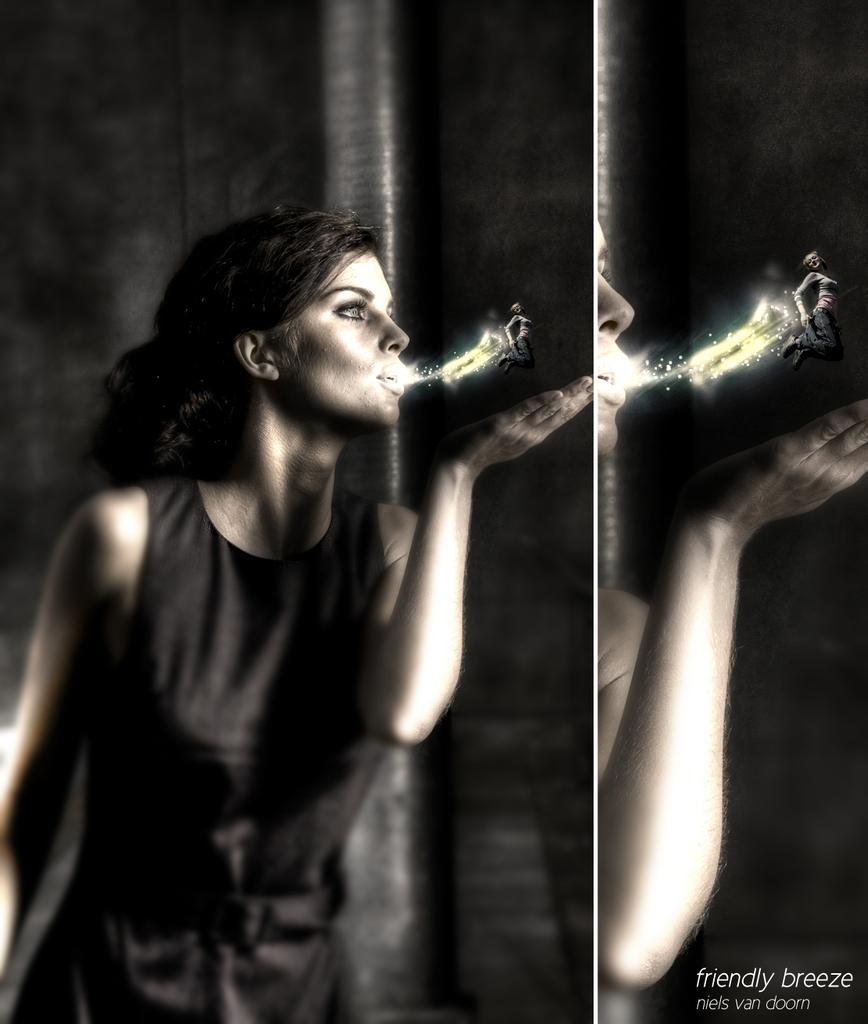In one or two sentences, can you explain what this image depicts? This is a collage of two images in which there is a person blowing a lilliput with spark and some text at the bottom of the image 